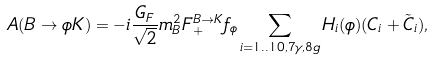<formula> <loc_0><loc_0><loc_500><loc_500>A ( B \to \phi K ) = - i \frac { G _ { F } } { \sqrt { 2 } } m _ { B } ^ { 2 } F _ { + } ^ { B \to K } f _ { \phi } \sum _ { i = 1 . . 1 0 , 7 \gamma , 8 g } H _ { i } ( \phi ) ( { C } _ { i } + { \tilde { C } } _ { i } ) ,</formula> 